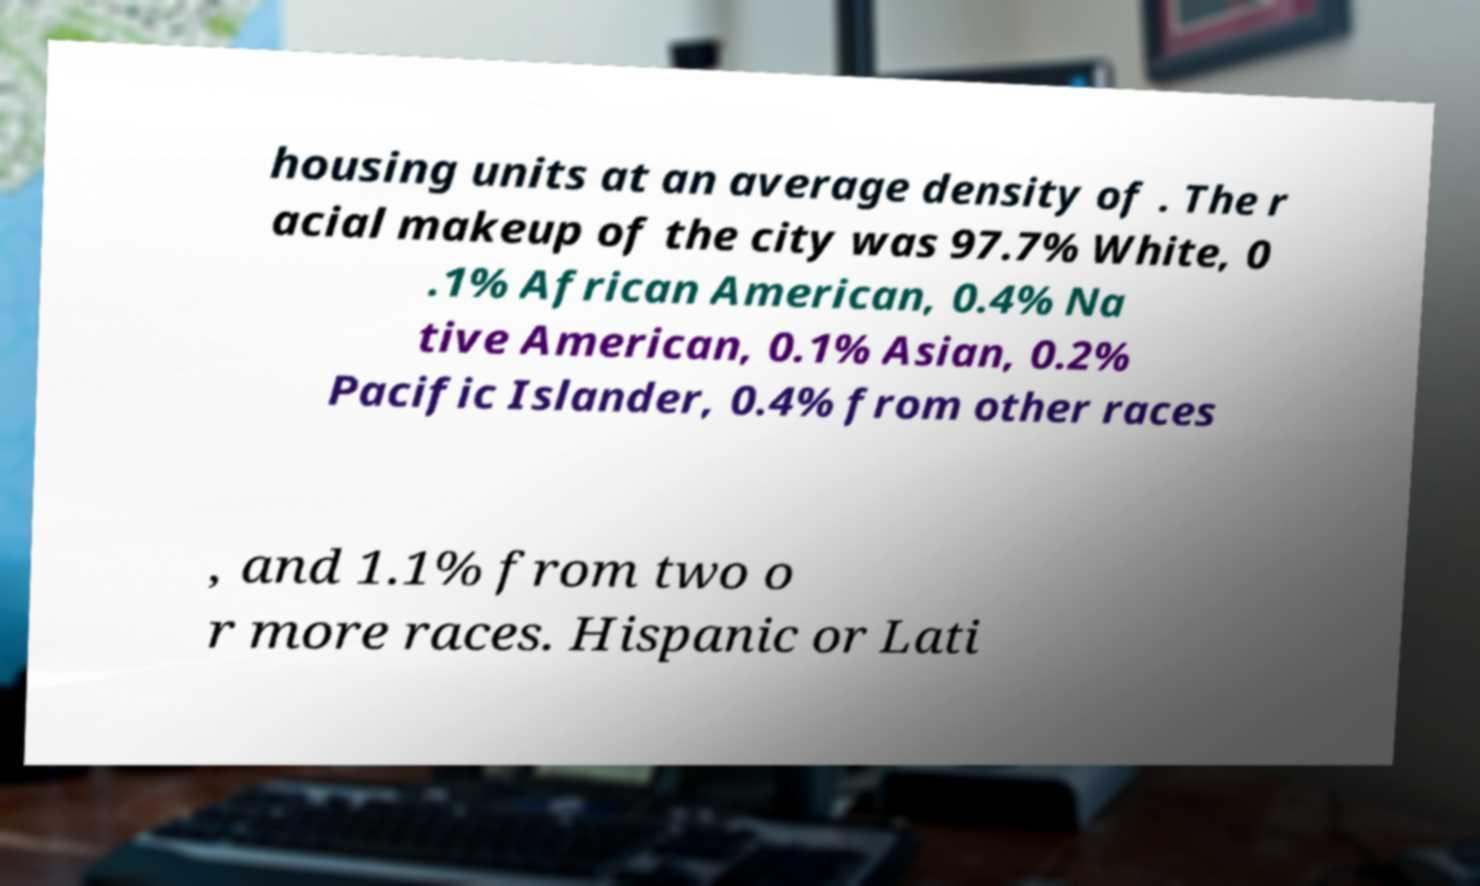Could you extract and type out the text from this image? housing units at an average density of . The r acial makeup of the city was 97.7% White, 0 .1% African American, 0.4% Na tive American, 0.1% Asian, 0.2% Pacific Islander, 0.4% from other races , and 1.1% from two o r more races. Hispanic or Lati 